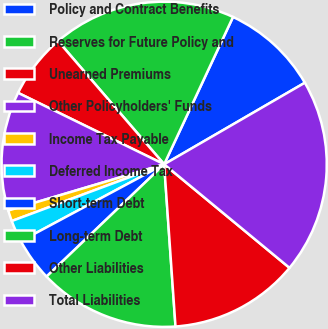<chart> <loc_0><loc_0><loc_500><loc_500><pie_chart><fcel>Policy and Contract Benefits<fcel>Reserves for Future Policy and<fcel>Unearned Premiums<fcel>Other Policyholders' Funds<fcel>Income Tax Payable<fcel>Deferred Income Tax<fcel>Short-term Debt<fcel>Long-term Debt<fcel>Other Liabilities<fcel>Total Liabilities<nl><fcel>9.68%<fcel>18.27%<fcel>6.45%<fcel>11.83%<fcel>1.08%<fcel>2.16%<fcel>4.3%<fcel>13.98%<fcel>12.9%<fcel>19.35%<nl></chart> 